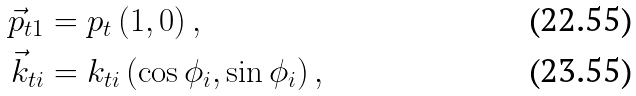Convert formula to latex. <formula><loc_0><loc_0><loc_500><loc_500>\vec { p } _ { t 1 } & = p _ { t } \, ( 1 , 0 ) \, , \\ \vec { k } _ { t i } & = k _ { t i } \, ( \cos \phi _ { i } , \sin \phi _ { i } ) \, ,</formula> 